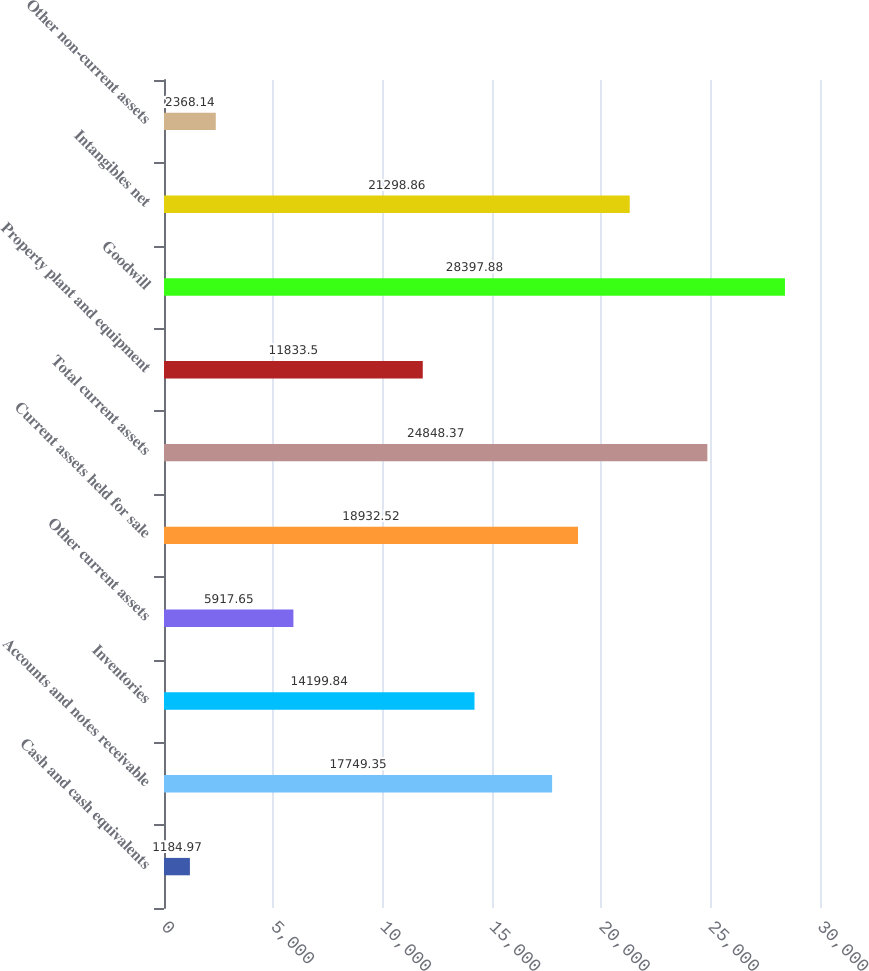Convert chart. <chart><loc_0><loc_0><loc_500><loc_500><bar_chart><fcel>Cash and cash equivalents<fcel>Accounts and notes receivable<fcel>Inventories<fcel>Other current assets<fcel>Current assets held for sale<fcel>Total current assets<fcel>Property plant and equipment<fcel>Goodwill<fcel>Intangibles net<fcel>Other non-current assets<nl><fcel>1184.97<fcel>17749.3<fcel>14199.8<fcel>5917.65<fcel>18932.5<fcel>24848.4<fcel>11833.5<fcel>28397.9<fcel>21298.9<fcel>2368.14<nl></chart> 